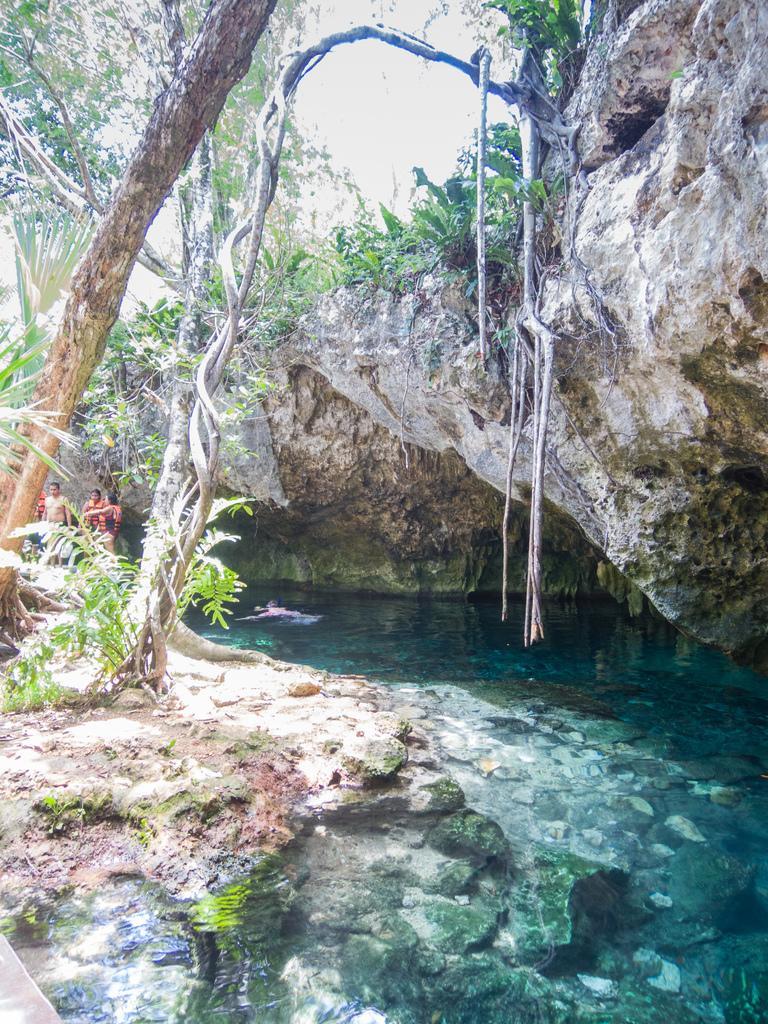How would you summarize this image in a sentence or two? This image is taken in outdoors. In the right side of the image there is a rock with plants on it. In the middle of the image there is a lake with water and few stones in it. In the left side of the image there are few trees and plants and four people are standing on the ground. In the background there are many trees and plants. 